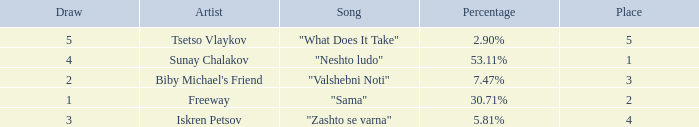What is the highest draw when the place is less than 3 and the percentage is 30.71%? 1.0. 